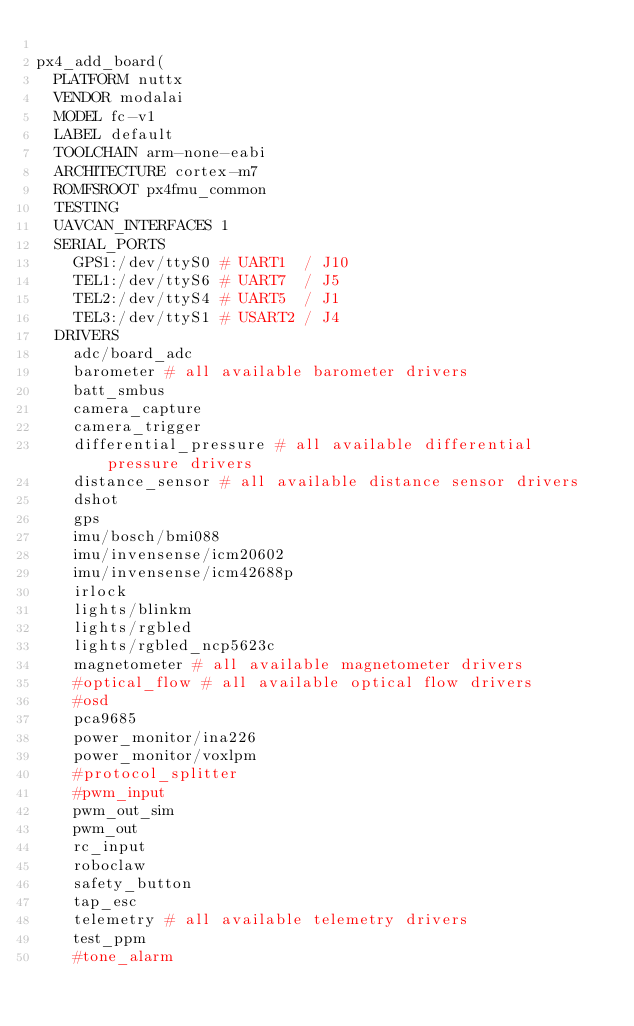<code> <loc_0><loc_0><loc_500><loc_500><_CMake_>
px4_add_board(
	PLATFORM nuttx
	VENDOR modalai
	MODEL fc-v1
	LABEL default
	TOOLCHAIN arm-none-eabi
	ARCHITECTURE cortex-m7
	ROMFSROOT px4fmu_common
	TESTING
	UAVCAN_INTERFACES 1
	SERIAL_PORTS
		GPS1:/dev/ttyS0 # UART1  / J10
		TEL1:/dev/ttyS6 # UART7  / J5
		TEL2:/dev/ttyS4 # UART5  / J1
		TEL3:/dev/ttyS1 # USART2 / J4
	DRIVERS
		adc/board_adc
		barometer # all available barometer drivers
		batt_smbus
		camera_capture
		camera_trigger
		differential_pressure # all available differential pressure drivers
		distance_sensor # all available distance sensor drivers
		dshot
		gps
		imu/bosch/bmi088
		imu/invensense/icm20602
		imu/invensense/icm42688p
		irlock
		lights/blinkm
		lights/rgbled
		lights/rgbled_ncp5623c
		magnetometer # all available magnetometer drivers
		#optical_flow # all available optical flow drivers
		#osd
		pca9685
		power_monitor/ina226
		power_monitor/voxlpm
		#protocol_splitter
		#pwm_input
		pwm_out_sim
		pwm_out
		rc_input
		roboclaw
		safety_button
		tap_esc
		telemetry # all available telemetry drivers
		test_ppm
		#tone_alarm</code> 